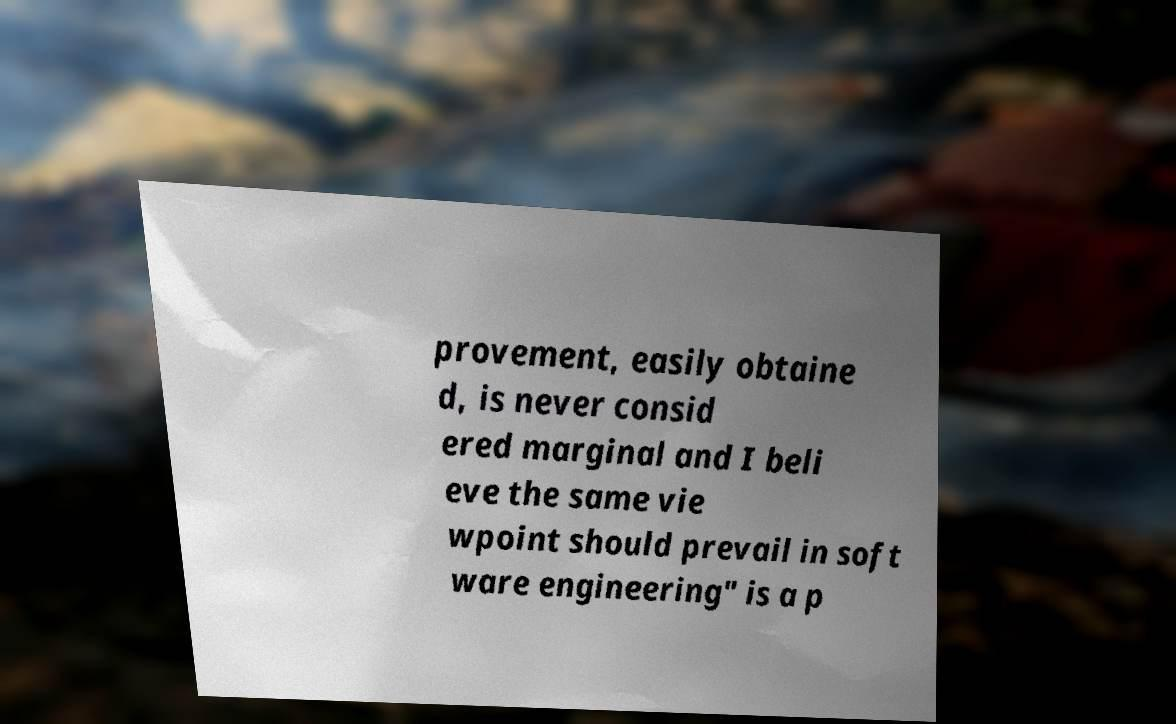For documentation purposes, I need the text within this image transcribed. Could you provide that? provement, easily obtaine d, is never consid ered marginal and I beli eve the same vie wpoint should prevail in soft ware engineering" is a p 